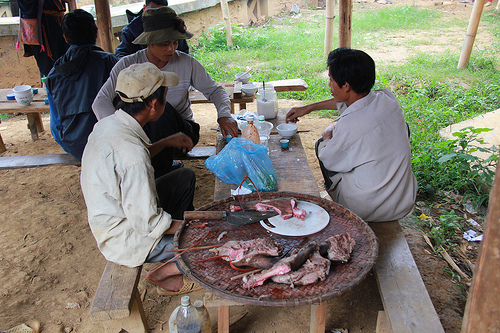<image>
Can you confirm if the man is next to the woman? Yes. The man is positioned adjacent to the woman, located nearby in the same general area. Is there a meat to the right of the man? No. The meat is not to the right of the man. The horizontal positioning shows a different relationship. 